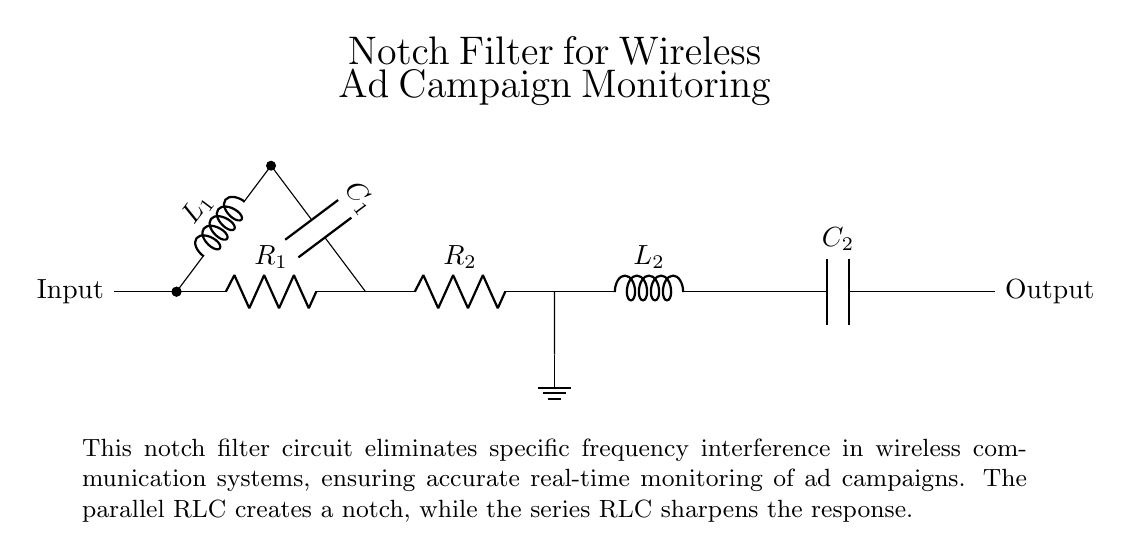What are the components present in the circuit? The circuit contains resistors, inductors, and capacitors. Specifically, it includes two resistors (R1 and R2), two inductors (L1 and L2), and two capacitors (C1 and C2).
Answer: resistors, inductors, capacitors What is the function of the capacitor C1? Capacitor C1 is part of the parallel RLC circuit that helps create the notch filter effect by allowing specific frequencies to pass while attenuating others. It works with the inductor L1 and resistor R1 to define the notch frequency.
Answer: notch filter effect How many branches does the circuit have? The circuit has two main branches: one is a parallel RLC branch (R1, L1, C1), and the other is a series RLC branch (R2, L2, C2). This branching is essential for the notch filter's performance.
Answer: two What is the role of the inductor L2? Inductor L2 is part of the series RLC section of the circuit, contributing to the creation of a sharper frequency response in the notch filter configuration alongside capacitor C2 and resistor R2.
Answer: sharper frequency response Which resistor is connected in series with the output? Resistor R2 is connected in series with the output, which is essential for limiting current and shaping the filter's overall response.
Answer: R2 What causes the notch effect in this circuit? The notch effect occurs due to the combination of the parallel RLC circuit (R1, L1, C1), which targets specific frequency components, and the series RLC circuit (R2, L2, C2), which refines the response. Together, they create a sharp attenuation at the notch frequency.
Answer: combination of RLC circuits What is the effect of adding a capacitor in parallel with L1? Adding C1 in parallel with L1 creates a resonant circuit that diminishes the amplitude of signals at a specific frequency, resulting in reduced interference within that range. This is key to the filter's function in wireless communication systems.
Answer: diminished amplitude at specific frequency 